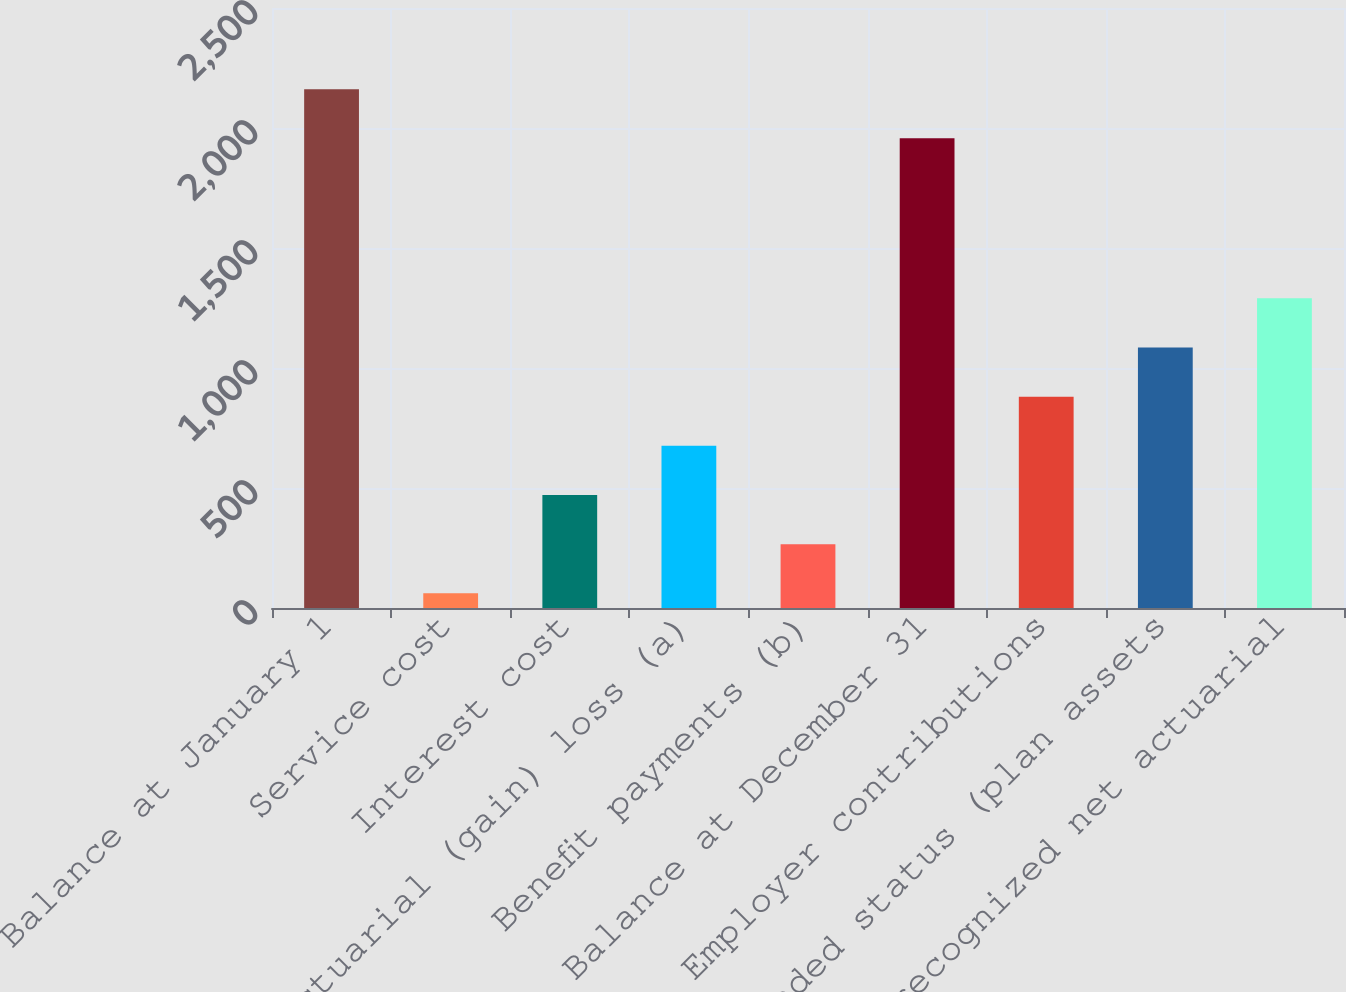Convert chart. <chart><loc_0><loc_0><loc_500><loc_500><bar_chart><fcel>Balance at January 1<fcel>Service cost<fcel>Interest cost<fcel>Actuarial (gain) loss (a)<fcel>Benefit payments (b)<fcel>Balance at December 31<fcel>Employer contributions<fcel>Funded status (plan assets<fcel>Unrecognized net actuarial<nl><fcel>2161.9<fcel>61<fcel>470.8<fcel>675.7<fcel>265.9<fcel>1957<fcel>880.6<fcel>1085.5<fcel>1290.4<nl></chart> 